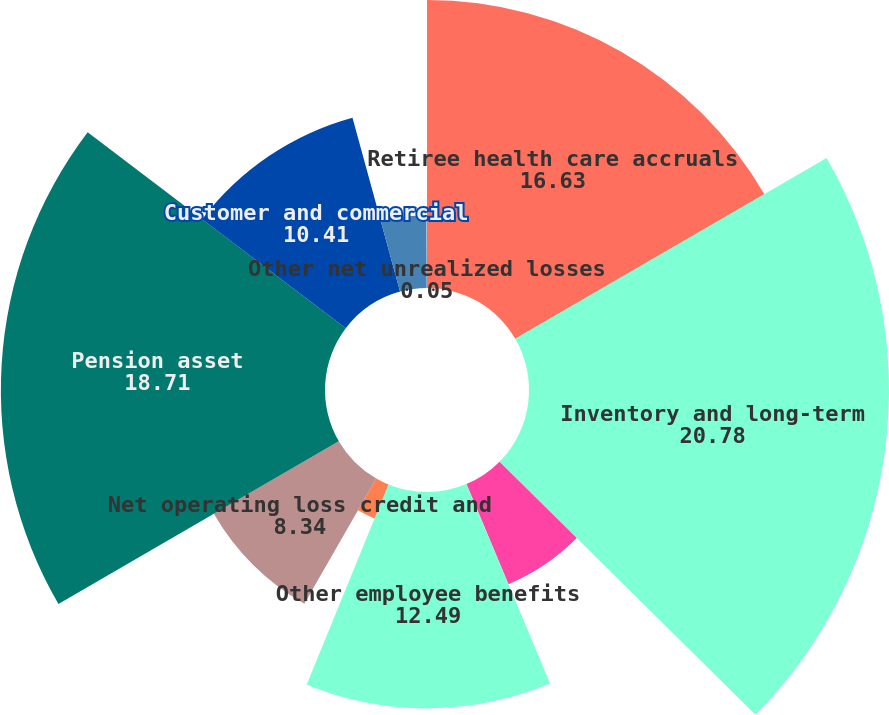Convert chart to OTSL. <chart><loc_0><loc_0><loc_500><loc_500><pie_chart><fcel>Retiree health care accruals<fcel>Inventory and long-term<fcel>Partnerships and joint<fcel>Other employee benefits<fcel>In-process research and<fcel>Net operating loss credit and<fcel>Pension asset<fcel>Customer and commercial<fcel>Unremitted earnings of non-US<fcel>Other net unrealized losses<nl><fcel>16.63%<fcel>20.78%<fcel>6.27%<fcel>12.49%<fcel>2.12%<fcel>8.34%<fcel>18.71%<fcel>10.41%<fcel>4.2%<fcel>0.05%<nl></chart> 